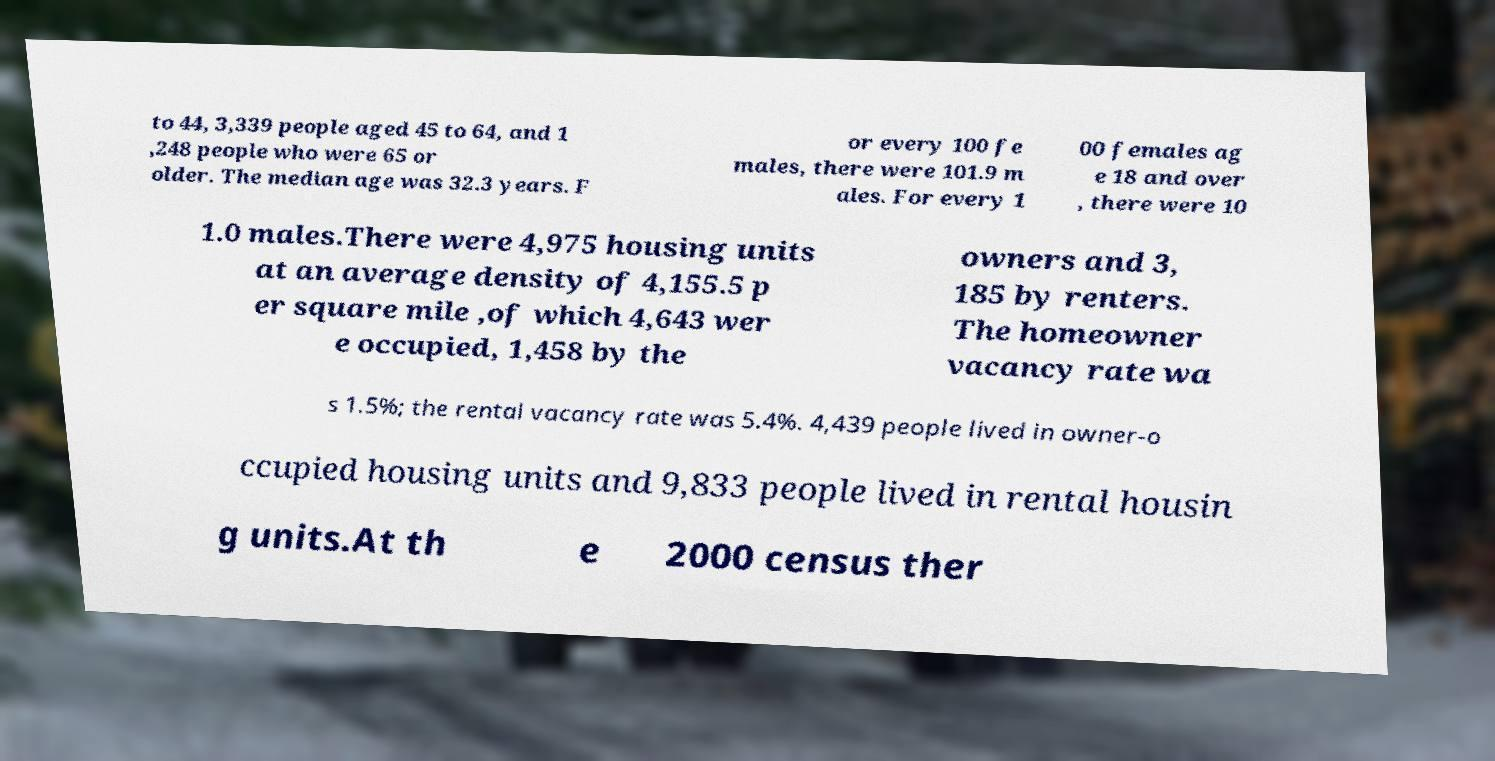For documentation purposes, I need the text within this image transcribed. Could you provide that? to 44, 3,339 people aged 45 to 64, and 1 ,248 people who were 65 or older. The median age was 32.3 years. F or every 100 fe males, there were 101.9 m ales. For every 1 00 females ag e 18 and over , there were 10 1.0 males.There were 4,975 housing units at an average density of 4,155.5 p er square mile ,of which 4,643 wer e occupied, 1,458 by the owners and 3, 185 by renters. The homeowner vacancy rate wa s 1.5%; the rental vacancy rate was 5.4%. 4,439 people lived in owner-o ccupied housing units and 9,833 people lived in rental housin g units.At th e 2000 census ther 